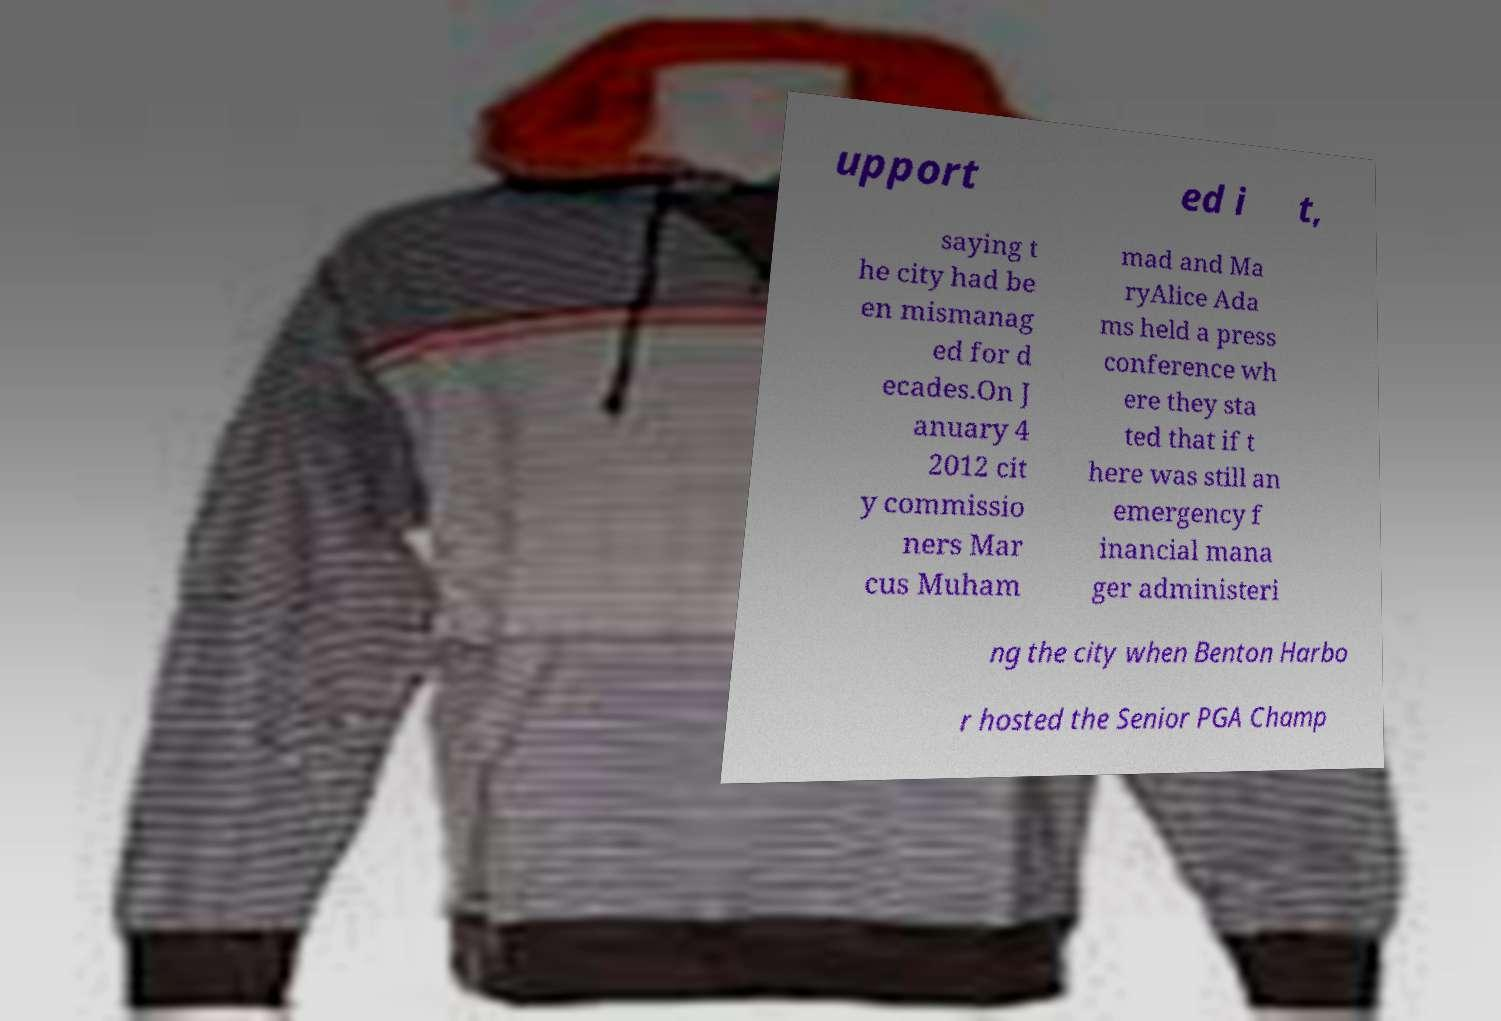Please read and relay the text visible in this image. What does it say? upport ed i t, saying t he city had be en mismanag ed for d ecades.On J anuary 4 2012 cit y commissio ners Mar cus Muham mad and Ma ryAlice Ada ms held a press conference wh ere they sta ted that if t here was still an emergency f inancial mana ger administeri ng the city when Benton Harbo r hosted the Senior PGA Champ 